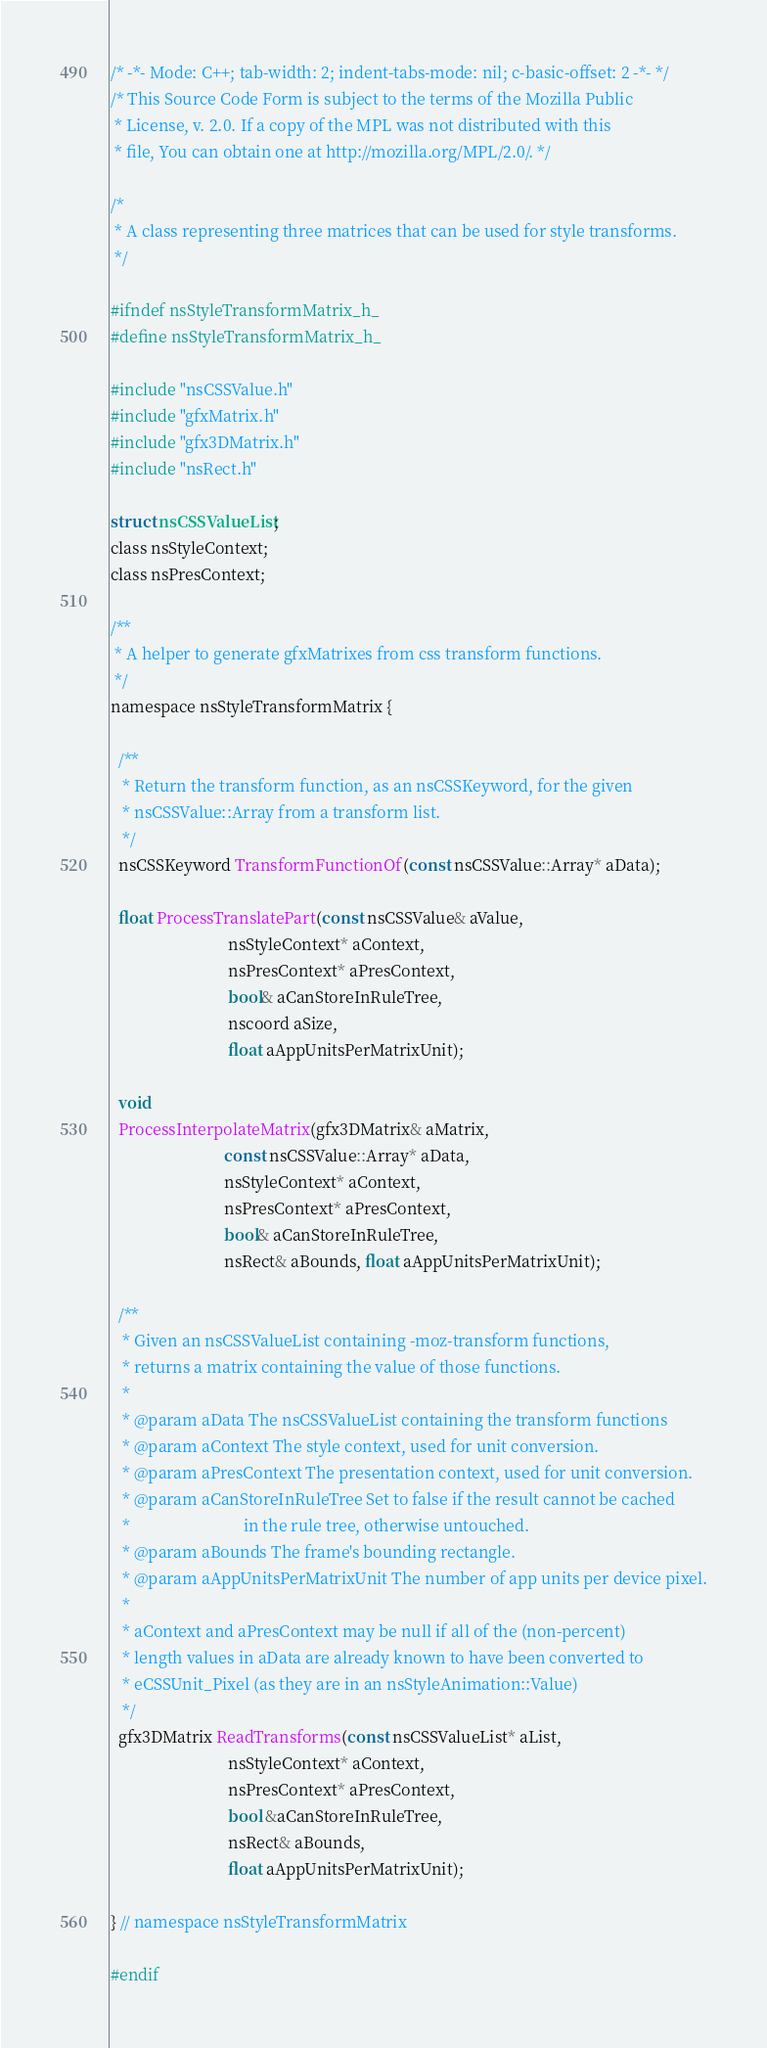<code> <loc_0><loc_0><loc_500><loc_500><_C_>/* -*- Mode: C++; tab-width: 2; indent-tabs-mode: nil; c-basic-offset: 2 -*- */
/* This Source Code Form is subject to the terms of the Mozilla Public
 * License, v. 2.0. If a copy of the MPL was not distributed with this
 * file, You can obtain one at http://mozilla.org/MPL/2.0/. */

/*
 * A class representing three matrices that can be used for style transforms.
 */

#ifndef nsStyleTransformMatrix_h_
#define nsStyleTransformMatrix_h_

#include "nsCSSValue.h"
#include "gfxMatrix.h"
#include "gfx3DMatrix.h"
#include "nsRect.h"

struct nsCSSValueList;
class nsStyleContext;
class nsPresContext;

/**
 * A helper to generate gfxMatrixes from css transform functions.
 */
namespace nsStyleTransformMatrix {
  
  /**
   * Return the transform function, as an nsCSSKeyword, for the given
   * nsCSSValue::Array from a transform list.
   */
  nsCSSKeyword TransformFunctionOf(const nsCSSValue::Array* aData);

  float ProcessTranslatePart(const nsCSSValue& aValue,
                             nsStyleContext* aContext,
                             nsPresContext* aPresContext,
                             bool& aCanStoreInRuleTree,
                             nscoord aSize,
                             float aAppUnitsPerMatrixUnit);

  void
  ProcessInterpolateMatrix(gfx3DMatrix& aMatrix,
                            const nsCSSValue::Array* aData,
                            nsStyleContext* aContext,
                            nsPresContext* aPresContext,
                            bool& aCanStoreInRuleTree,
                            nsRect& aBounds, float aAppUnitsPerMatrixUnit);

  /**
   * Given an nsCSSValueList containing -moz-transform functions,
   * returns a matrix containing the value of those functions.
   *
   * @param aData The nsCSSValueList containing the transform functions
   * @param aContext The style context, used for unit conversion.
   * @param aPresContext The presentation context, used for unit conversion.
   * @param aCanStoreInRuleTree Set to false if the result cannot be cached
   *                            in the rule tree, otherwise untouched.
   * @param aBounds The frame's bounding rectangle.
   * @param aAppUnitsPerMatrixUnit The number of app units per device pixel.
   *
   * aContext and aPresContext may be null if all of the (non-percent)
   * length values in aData are already known to have been converted to
   * eCSSUnit_Pixel (as they are in an nsStyleAnimation::Value)
   */
  gfx3DMatrix ReadTransforms(const nsCSSValueList* aList,
                             nsStyleContext* aContext,
                             nsPresContext* aPresContext,
                             bool &aCanStoreInRuleTree,
                             nsRect& aBounds,
                             float aAppUnitsPerMatrixUnit);

} // namespace nsStyleTransformMatrix

#endif
</code> 